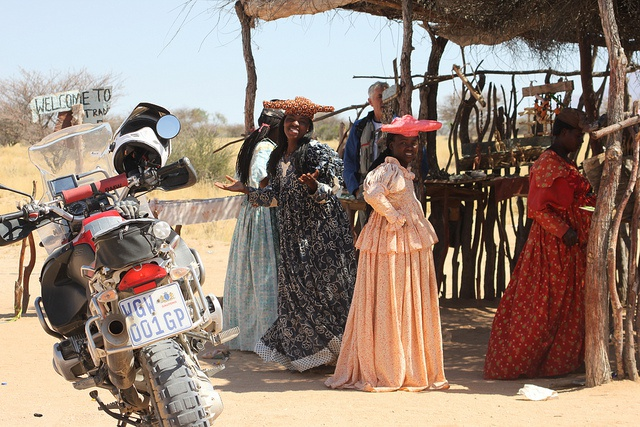Describe the objects in this image and their specific colors. I can see motorcycle in lavender, black, lightgray, gray, and tan tones, people in lavender, tan, and salmon tones, people in lavender, black, gray, and maroon tones, people in lavender, maroon, black, and brown tones, and people in lavender, darkgray, gray, and black tones in this image. 